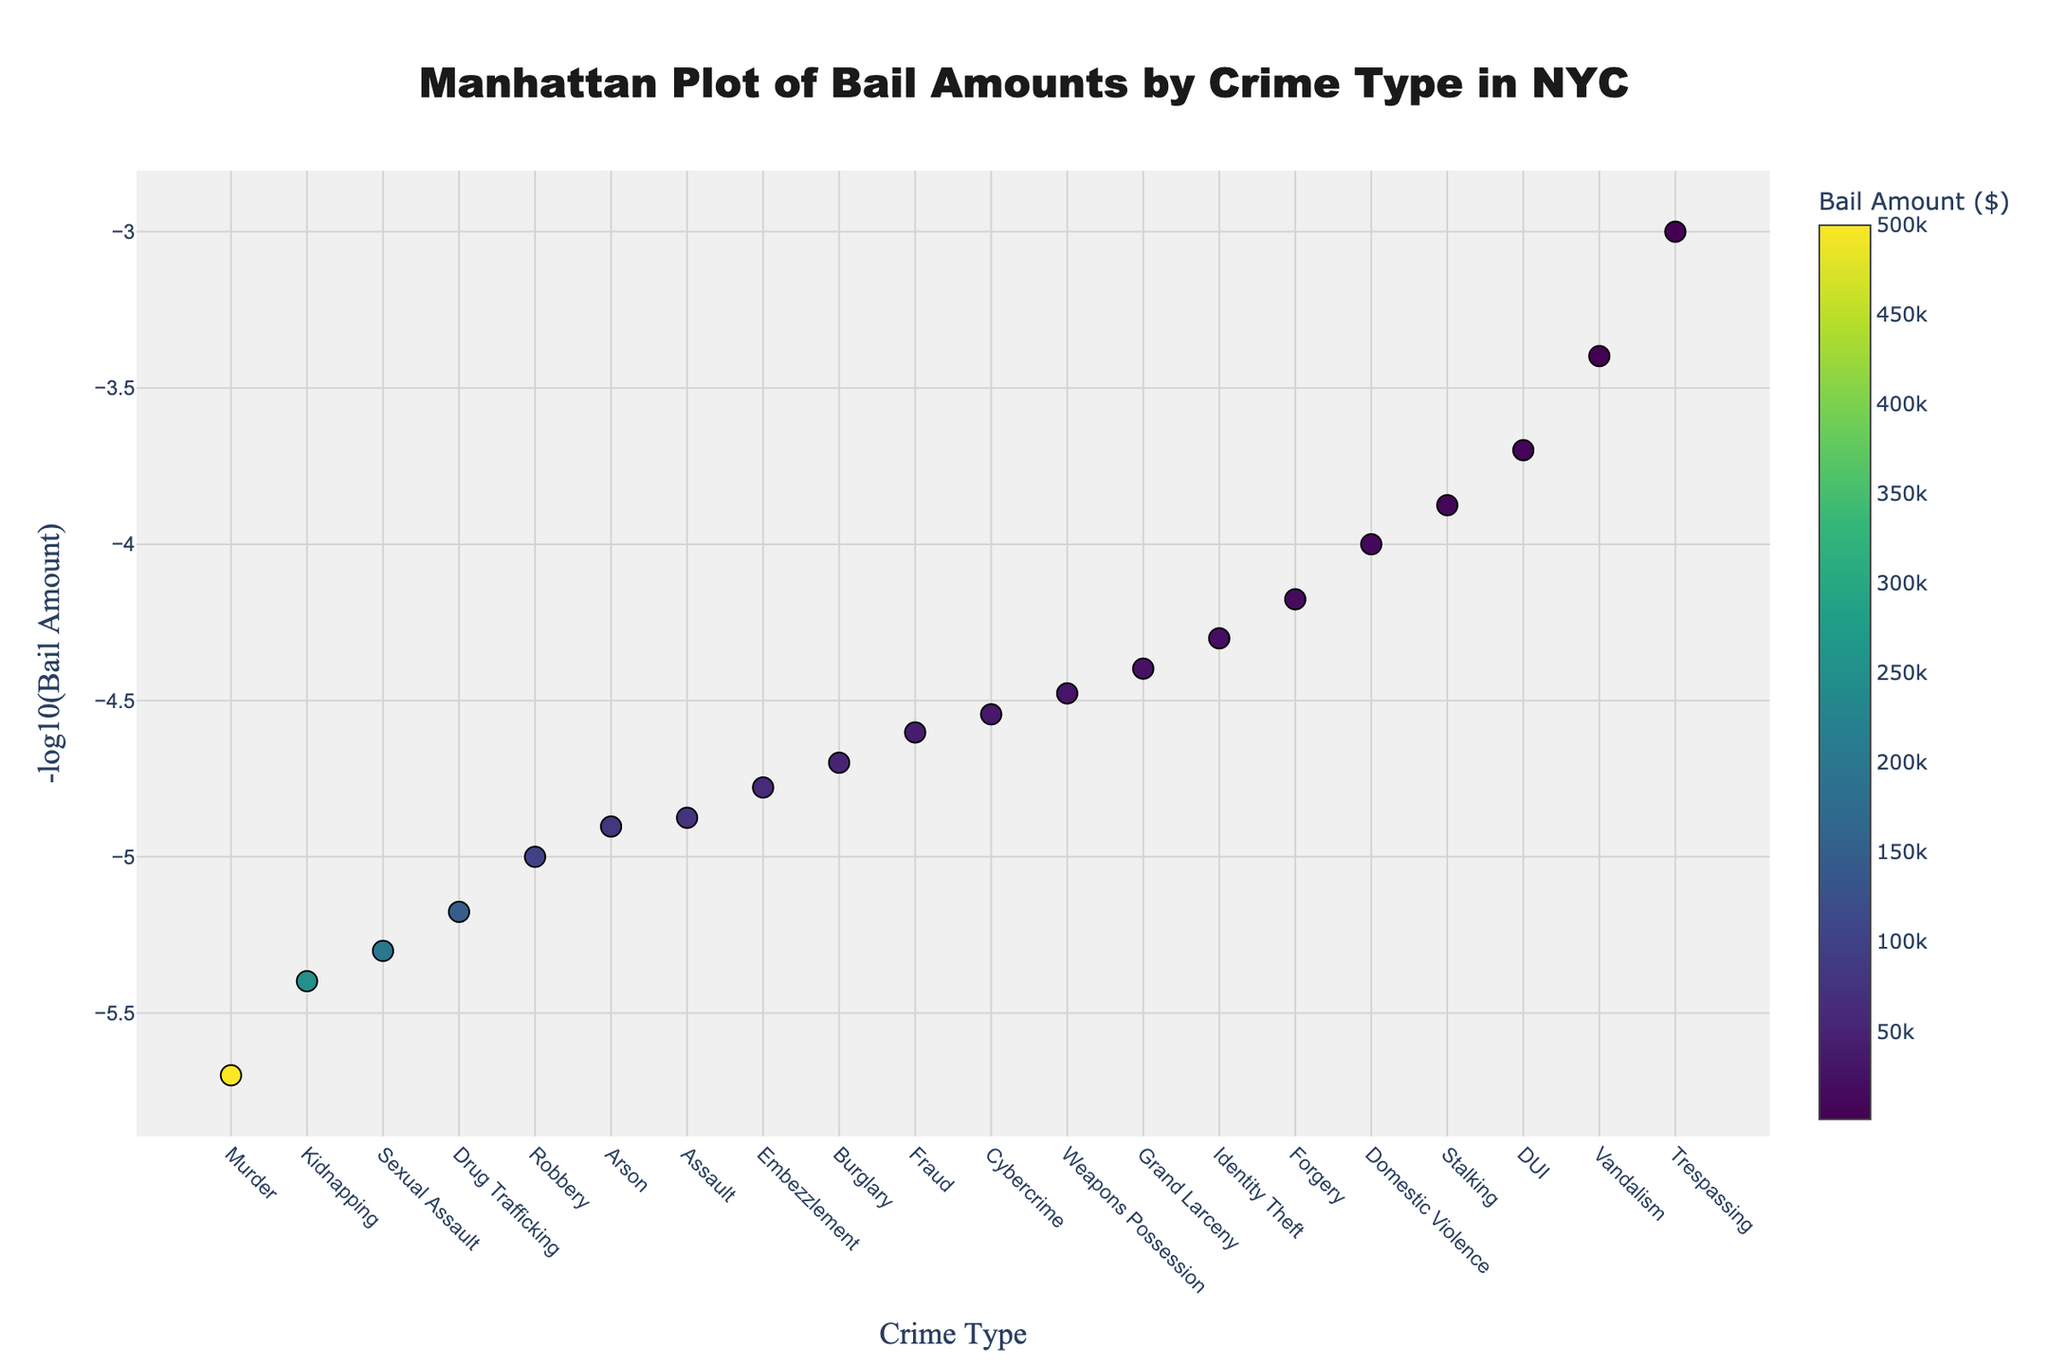What's the highest bail amount for any crime? The highest bail amount can be identified as the data point with the smallest -log10 value (closest to zero). The data label confirms that Murder has the highest bail amount.
Answer: $500,000 What type of crime has the lowest bail amount? The lowest bail amount will appear as the highest -log10 value. The data label indicates that Trespassing holds this spot.
Answer: Trespassing How many types of crimes have bail amounts greater than $100,000? One needs to count the number of data points with an annotation showing bail amounts above $100,000. These include Murder, Kidnapping, Sexual Assault, Drug Trafficking, and Robbery.
Answer: 5 Which crime has a bail amount of $40,000? By examining the data points and their labels, Fraud stands out as the crime with a bail amount of $40,000.
Answer: Fraud What's the difference in bail amount between Assault and Arson? The bail amount for Assault is $75,000, and for Arson, it's $80,000. The difference is calculated as $80,000 - $75,000.
Answer: $5,000 Which crime has a higher bail amount, Embezzlement or Cybercrime? By comparing the values, Embezzlement has a bail amount of $60,000, and Cybercrime has $35,000. Thus, Embezzlement has a higher bail amount.
Answer: Embezzlement How are the bail amounts distributed among violent crimes like Murder, Assault, and Robbery? Murder has the highest bail at $500,000, followed by Robbery at $100,000, and Assault at $75,000.
Answer: Highest for Murder, followed by Robbery, and then Assault What is the median bail amount for the crimes listed? To find the median value, sort all bail amounts, then find the middle value. This analysis reveals it to be $35,000.
Answer: $35,000 How does the -log10(bail amount) value for Grand Larceny compare to that of Weapons Possession? Grand Larceny's -log10 value is calculated from $25,000, while for Weapons Possession, it's from $30,000. Weapons Possession will have a slightly smaller -log10 value compared to Grand Larceny.
Answer: Grand Larceny higher Are there more crimes with bail amounts under $50,000 or over $150,000? Counting the number of data points, there are more crimes with bail amounts under $50,000 compared to those over $150,000.
Answer: Under $50,000 